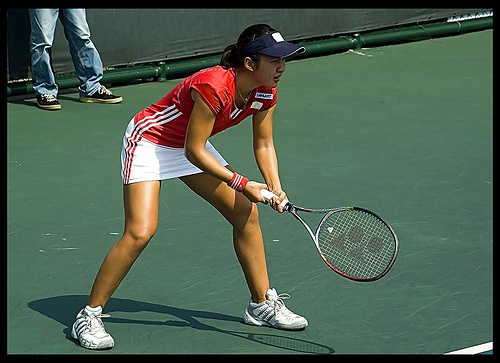Describe the objects in this image and their specific colors. I can see people in black, maroon, white, and teal tones, tennis racket in black, teal, darkgray, and gray tones, and people in black, blue, lightgray, and lightblue tones in this image. 